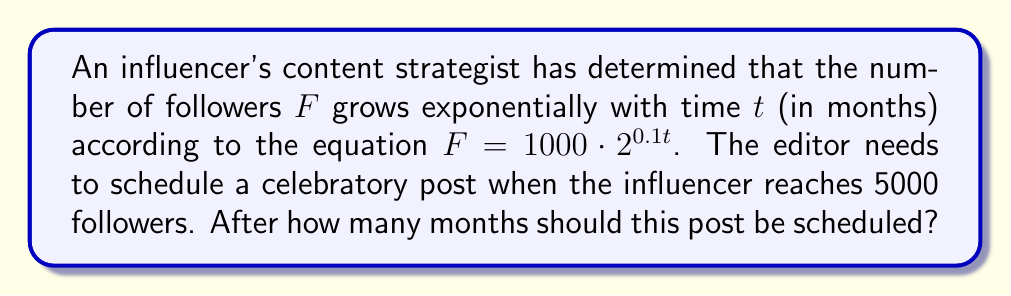Can you solve this math problem? Let's approach this step-by-step:

1) We start with the equation: $F = 1000 \cdot 2^{0.1t}$

2) We want to find $t$ when $F = 5000$. So, let's substitute this:

   $5000 = 1000 \cdot 2^{0.1t}$

3) Divide both sides by 1000:

   $5 = 2^{0.1t}$

4) Now, we can apply the logarithm (base 2) to both sides:

   $\log_2(5) = \log_2(2^{0.1t})$

5) Using the logarithm property $\log_a(a^x) = x$, we get:

   $\log_2(5) = 0.1t$

6) Now, we can solve for $t$:

   $t = \frac{\log_2(5)}{0.1}$

7) Calculate this value:

   $t = \frac{\log_2(5)}{0.1} \approx 23.22$ months

8) Since we can't schedule for a fractional month, we round up to the next whole month.
Answer: 24 months 